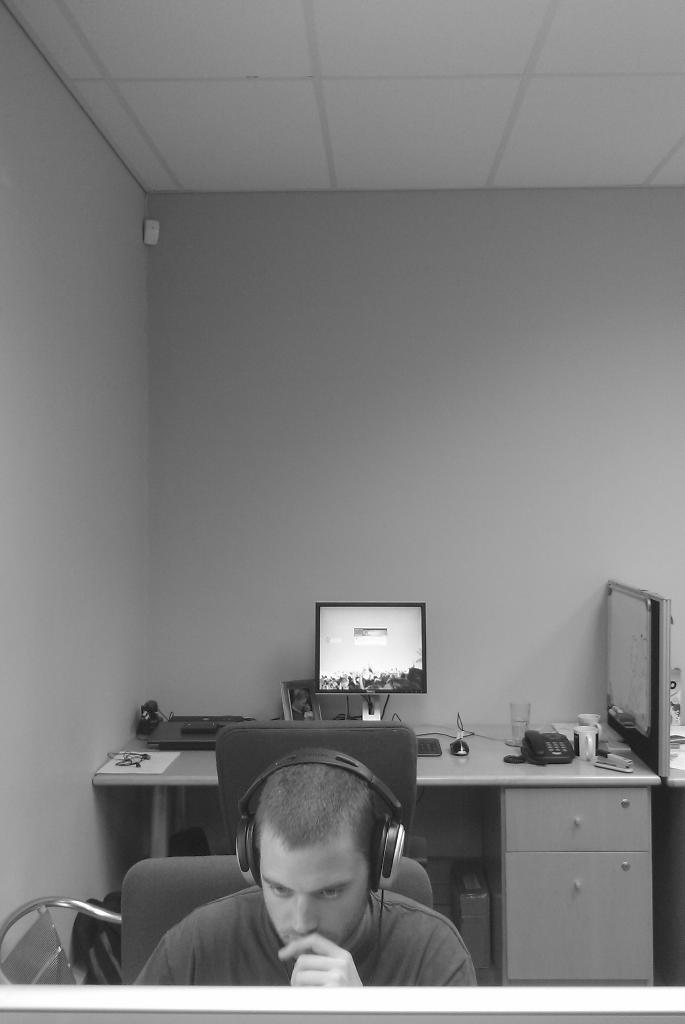Describe this image in one or two sentences. In this image we can see a person who is looking at some monitor or something which is not visible and he is wearing headphones. He is sitting on chair. Behind him, there is a table desk on which there is a laptop and things like telephone, glass and tea cup are present and it seems like a well furnished room. 